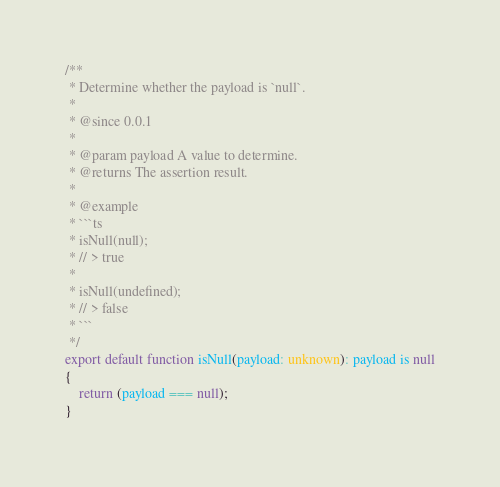<code> <loc_0><loc_0><loc_500><loc_500><_TypeScript_>/**
 * Determine whether the payload is `null`.
 * 
 * @since 0.0.1
 * 
 * @param payload A value to determine.
 * @returns The assertion result.
 * 
 * @example
 * ```ts
 * isNull(null);
 * // > true
 * 
 * isNull(undefined);
 * // > false
 * ```
 */
export default function isNull(payload: unknown): payload is null
{
    return (payload === null);
}
</code> 